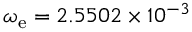Convert formula to latex. <formula><loc_0><loc_0><loc_500><loc_500>\omega _ { e } = 2 . 5 5 0 2 \times 1 0 ^ { - 3 }</formula> 